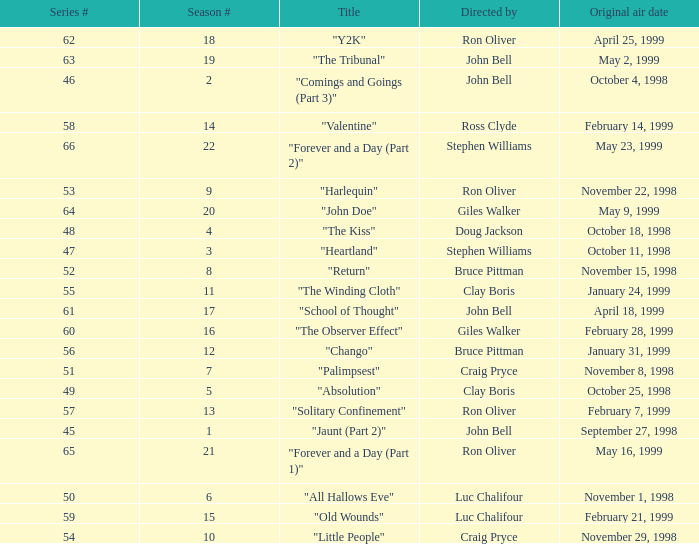Which Original air date has a Season # smaller than 21, and a Title of "palimpsest"? November 8, 1998. 